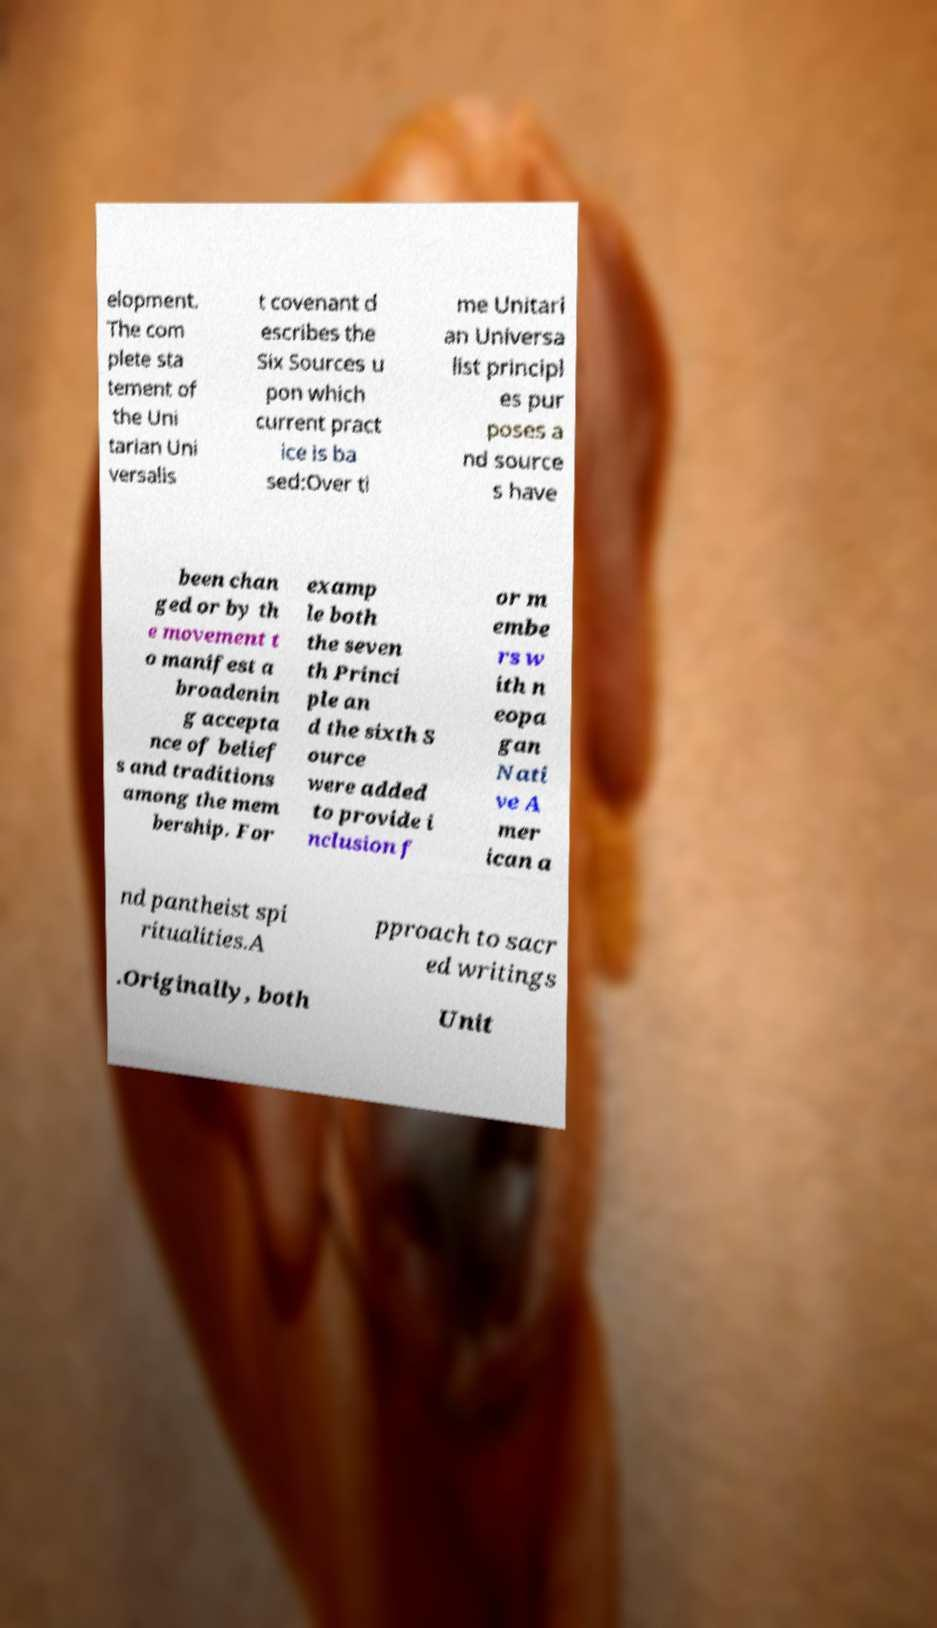Could you extract and type out the text from this image? elopment. The com plete sta tement of the Uni tarian Uni versalis t covenant d escribes the Six Sources u pon which current pract ice is ba sed:Over ti me Unitari an Universa list principl es pur poses a nd source s have been chan ged or by th e movement t o manifest a broadenin g accepta nce of belief s and traditions among the mem bership. For examp le both the seven th Princi ple an d the sixth S ource were added to provide i nclusion f or m embe rs w ith n eopa gan Nati ve A mer ican a nd pantheist spi ritualities.A pproach to sacr ed writings .Originally, both Unit 